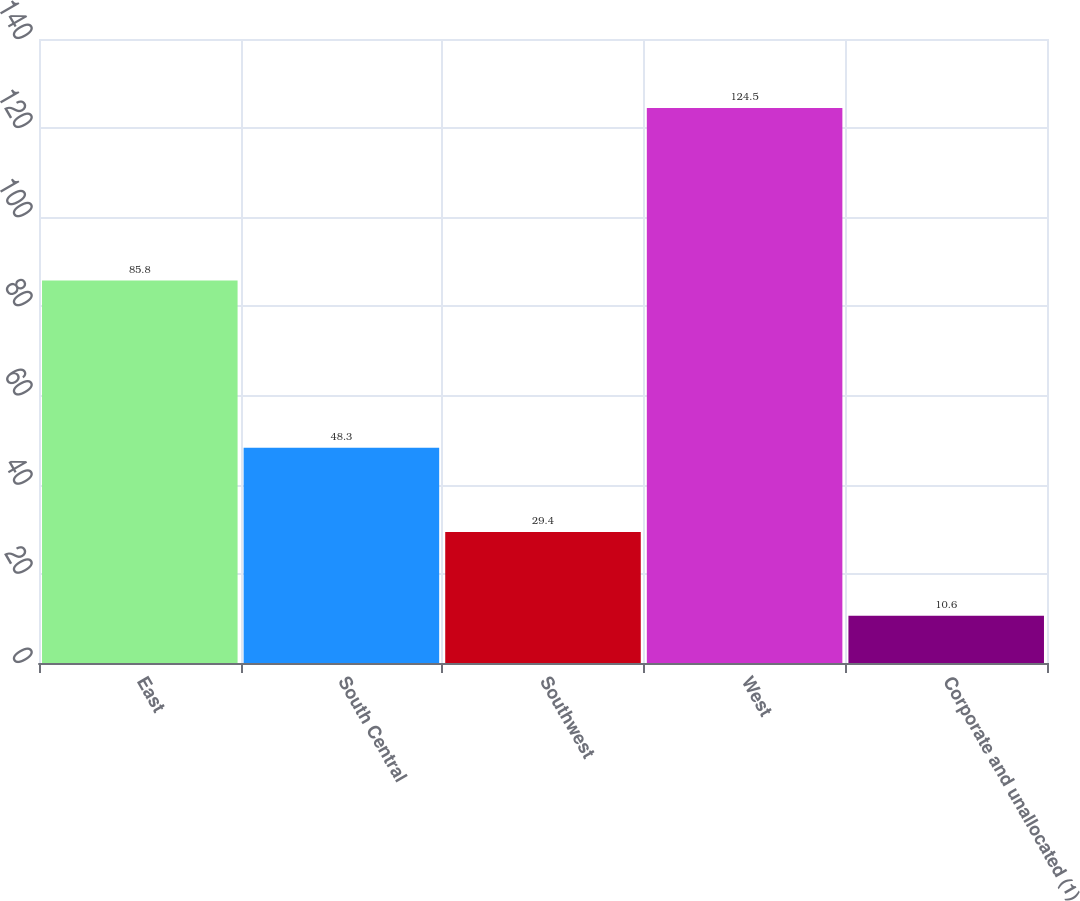Convert chart. <chart><loc_0><loc_0><loc_500><loc_500><bar_chart><fcel>East<fcel>South Central<fcel>Southwest<fcel>West<fcel>Corporate and unallocated (1)<nl><fcel>85.8<fcel>48.3<fcel>29.4<fcel>124.5<fcel>10.6<nl></chart> 